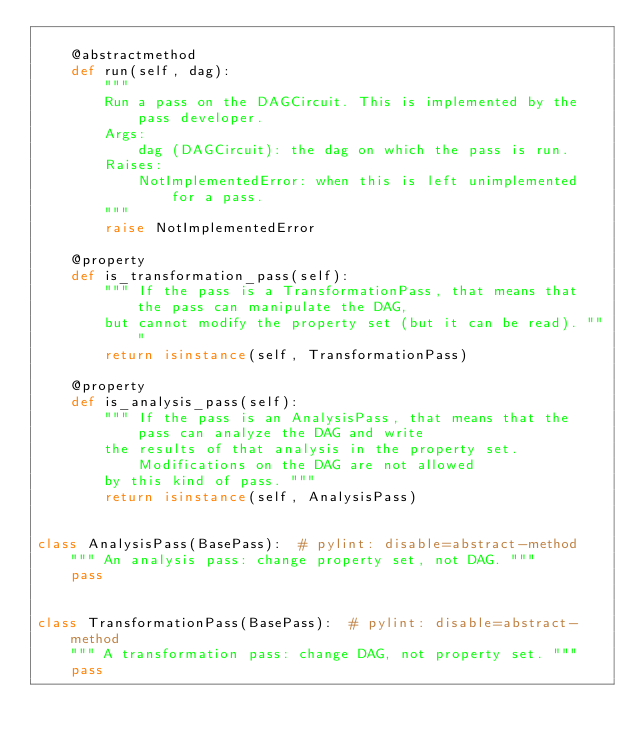<code> <loc_0><loc_0><loc_500><loc_500><_Python_>
    @abstractmethod
    def run(self, dag):
        """
        Run a pass on the DAGCircuit. This is implemented by the pass developer.
        Args:
            dag (DAGCircuit): the dag on which the pass is run.
        Raises:
            NotImplementedError: when this is left unimplemented for a pass.
        """
        raise NotImplementedError

    @property
    def is_transformation_pass(self):
        """ If the pass is a TransformationPass, that means that the pass can manipulate the DAG,
        but cannot modify the property set (but it can be read). """
        return isinstance(self, TransformationPass)

    @property
    def is_analysis_pass(self):
        """ If the pass is an AnalysisPass, that means that the pass can analyze the DAG and write
        the results of that analysis in the property set. Modifications on the DAG are not allowed
        by this kind of pass. """
        return isinstance(self, AnalysisPass)


class AnalysisPass(BasePass):  # pylint: disable=abstract-method
    """ An analysis pass: change property set, not DAG. """
    pass


class TransformationPass(BasePass):  # pylint: disable=abstract-method
    """ A transformation pass: change DAG, not property set. """
    pass
</code> 